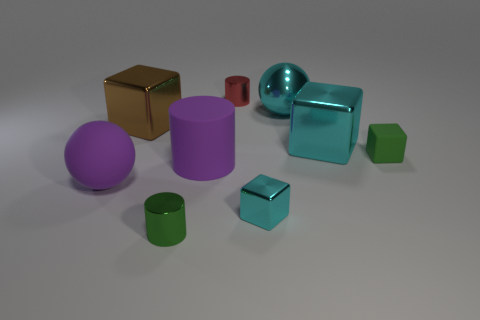How many tiny yellow matte objects are there?
Provide a succinct answer. 0. What number of tiny things are the same color as the large shiny sphere?
Your answer should be compact. 1. Does the small shiny thing left of the small red metal cylinder have the same shape as the large purple object that is to the right of the big brown object?
Give a very brief answer. Yes. There is a big metal cube left of the cyan thing that is in front of the sphere left of the purple rubber cylinder; what is its color?
Your answer should be very brief. Brown. There is a large shiny block that is to the right of the metal ball; what color is it?
Give a very brief answer. Cyan. There is a rubber object that is the same size as the rubber cylinder; what is its color?
Offer a terse response. Purple. Is the red metal thing the same size as the brown block?
Your response must be concise. No. How many shiny things are in front of the red shiny object?
Provide a short and direct response. 5. How many things are large objects that are left of the brown metallic cube or big yellow cubes?
Provide a short and direct response. 1. Is the number of cyan cubes that are to the left of the purple cylinder greater than the number of large things that are in front of the tiny green cube?
Your response must be concise. No. 